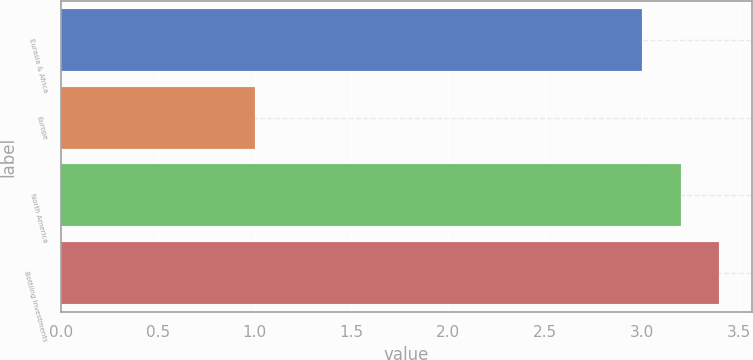<chart> <loc_0><loc_0><loc_500><loc_500><bar_chart><fcel>Eurasia & Africa<fcel>Europe<fcel>North America<fcel>Bottling Investments<nl><fcel>3<fcel>1<fcel>3.2<fcel>3.4<nl></chart> 